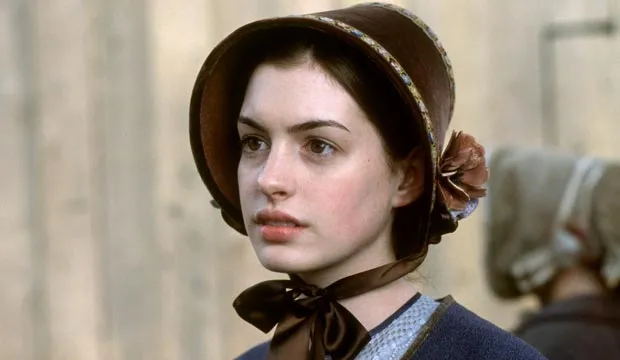What are some possible emotions she might be feeling in this moment? She might be feeling a combination of apprehension, determination, and contemplation. Her serious expression suggests she is deep in thought and possibly facing a difficult decision or reflecting on a significant event. What could the blurred figure in the background be doing? The blurred figure in the background might be engaged in a casual conversation or performing a daily task. Their indistinct form suggests that they are not the focal point but contribute to the setting’s atmosphere, potentially signifying the normalcy and routine of life surrounding the main subject's moment of introspection. If this image were a scene from a novel, how would the author describe it? Eleanor stood motionless by the weathered wooden wall, her gaze lost in the horizon. The blue of her gown, though simple, stood in stark relief against the muted tones of the village behind her. The bonnet, tied securely with a black ribbon, framed her face like a portrait from another era, her expression revealing the depth of the unspoken thoughts that occupied her mind. In the background, the blurred figure of a villager moved with purpose, a silent testament to the life that continued around her, indifferent to the silent storm raging within her heart. What if the background figure suddenly came into focus? How would it change the dynamics of this scene? If the background figure suddenly came into focus, it would add another layer of interaction and context to the scene. Perhaps this figure is someone pivotal to Eleanor’s story, like a confidant or a figure of authority. The dynamics would shift from a solitary moment of contemplation to a possible exchange or confrontation, potentially revealing more about the plot and the characters involved. 